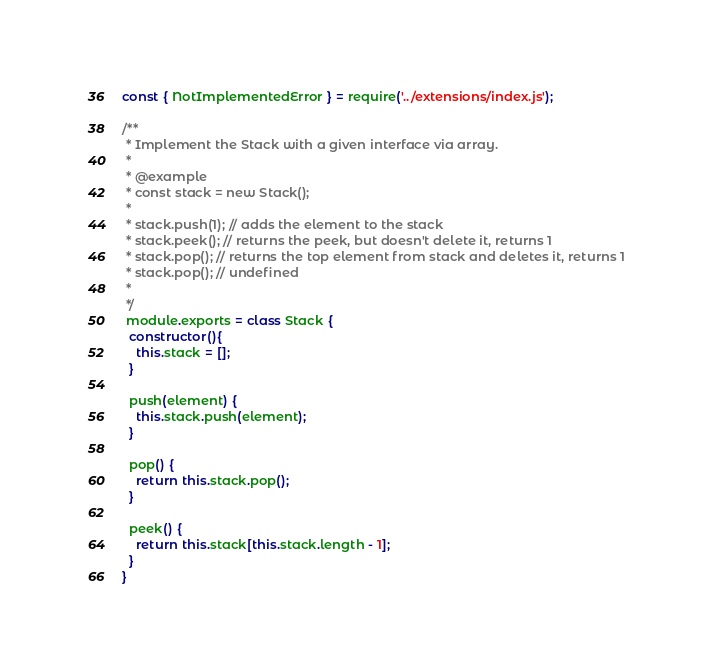Convert code to text. <code><loc_0><loc_0><loc_500><loc_500><_JavaScript_>const { NotImplementedError } = require('../extensions/index.js');

/**
 * Implement the Stack with a given interface via array.
 *
 * @example
 * const stack = new Stack();
 *
 * stack.push(1); // adds the element to the stack
 * stack.peek(); // returns the peek, but doesn't delete it, returns 1
 * stack.pop(); // returns the top element from stack and deletes it, returns 1
 * stack.pop(); // undefined
 *
 */
 module.exports = class Stack {
  constructor(){
    this.stack = [];
  }

  push(element) {
    this.stack.push(element);
  }

  pop() {
    return this.stack.pop();
  }

  peek() {
    return this.stack[this.stack.length - 1];
  }
}
</code> 